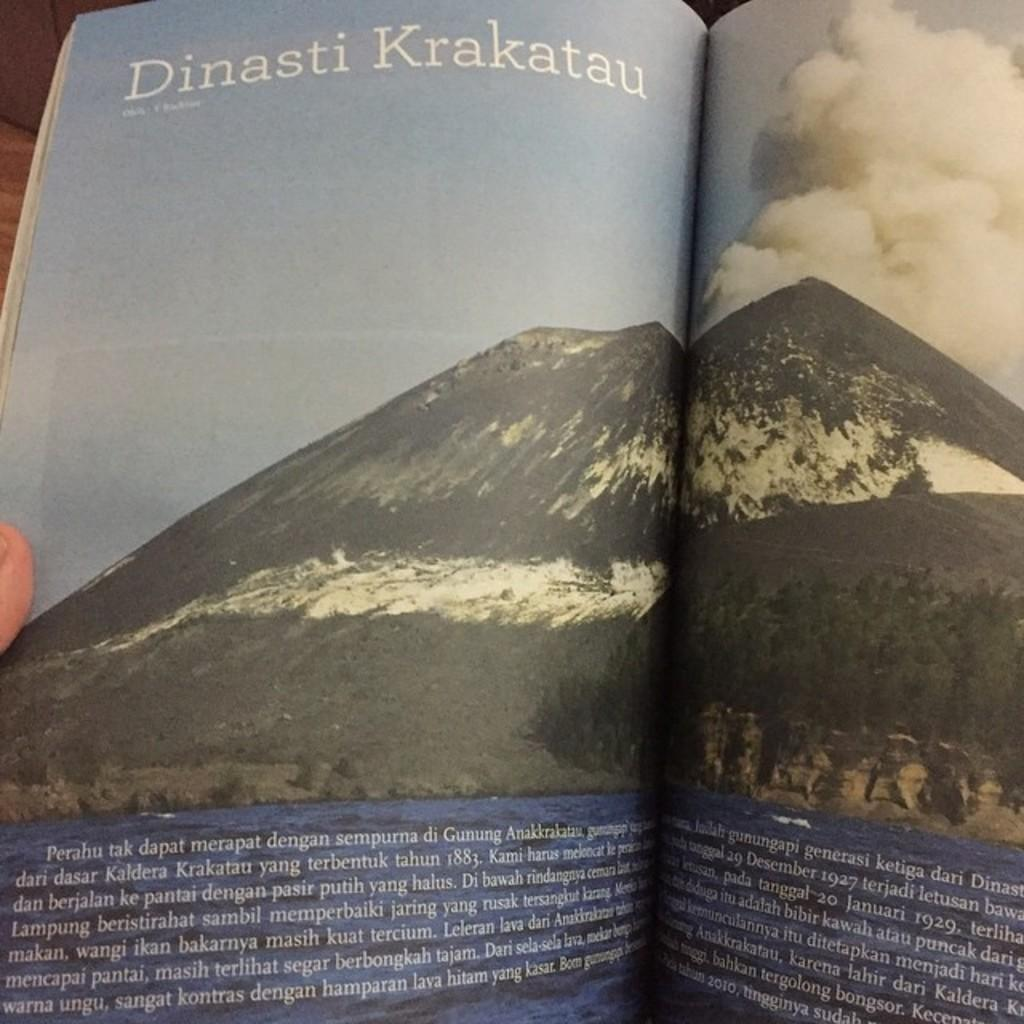Provide a one-sentence caption for the provided image. An article from a magazine titled Dinasti Krakatau. 